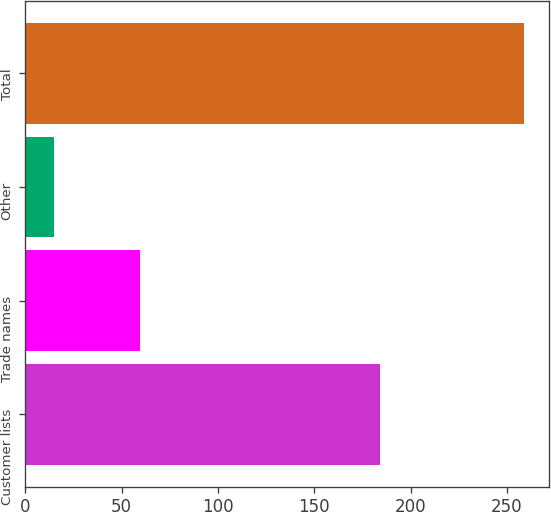Convert chart. <chart><loc_0><loc_0><loc_500><loc_500><bar_chart><fcel>Customer lists<fcel>Trade names<fcel>Other<fcel>Total<nl><fcel>184<fcel>59.7<fcel>15.1<fcel>258.8<nl></chart> 